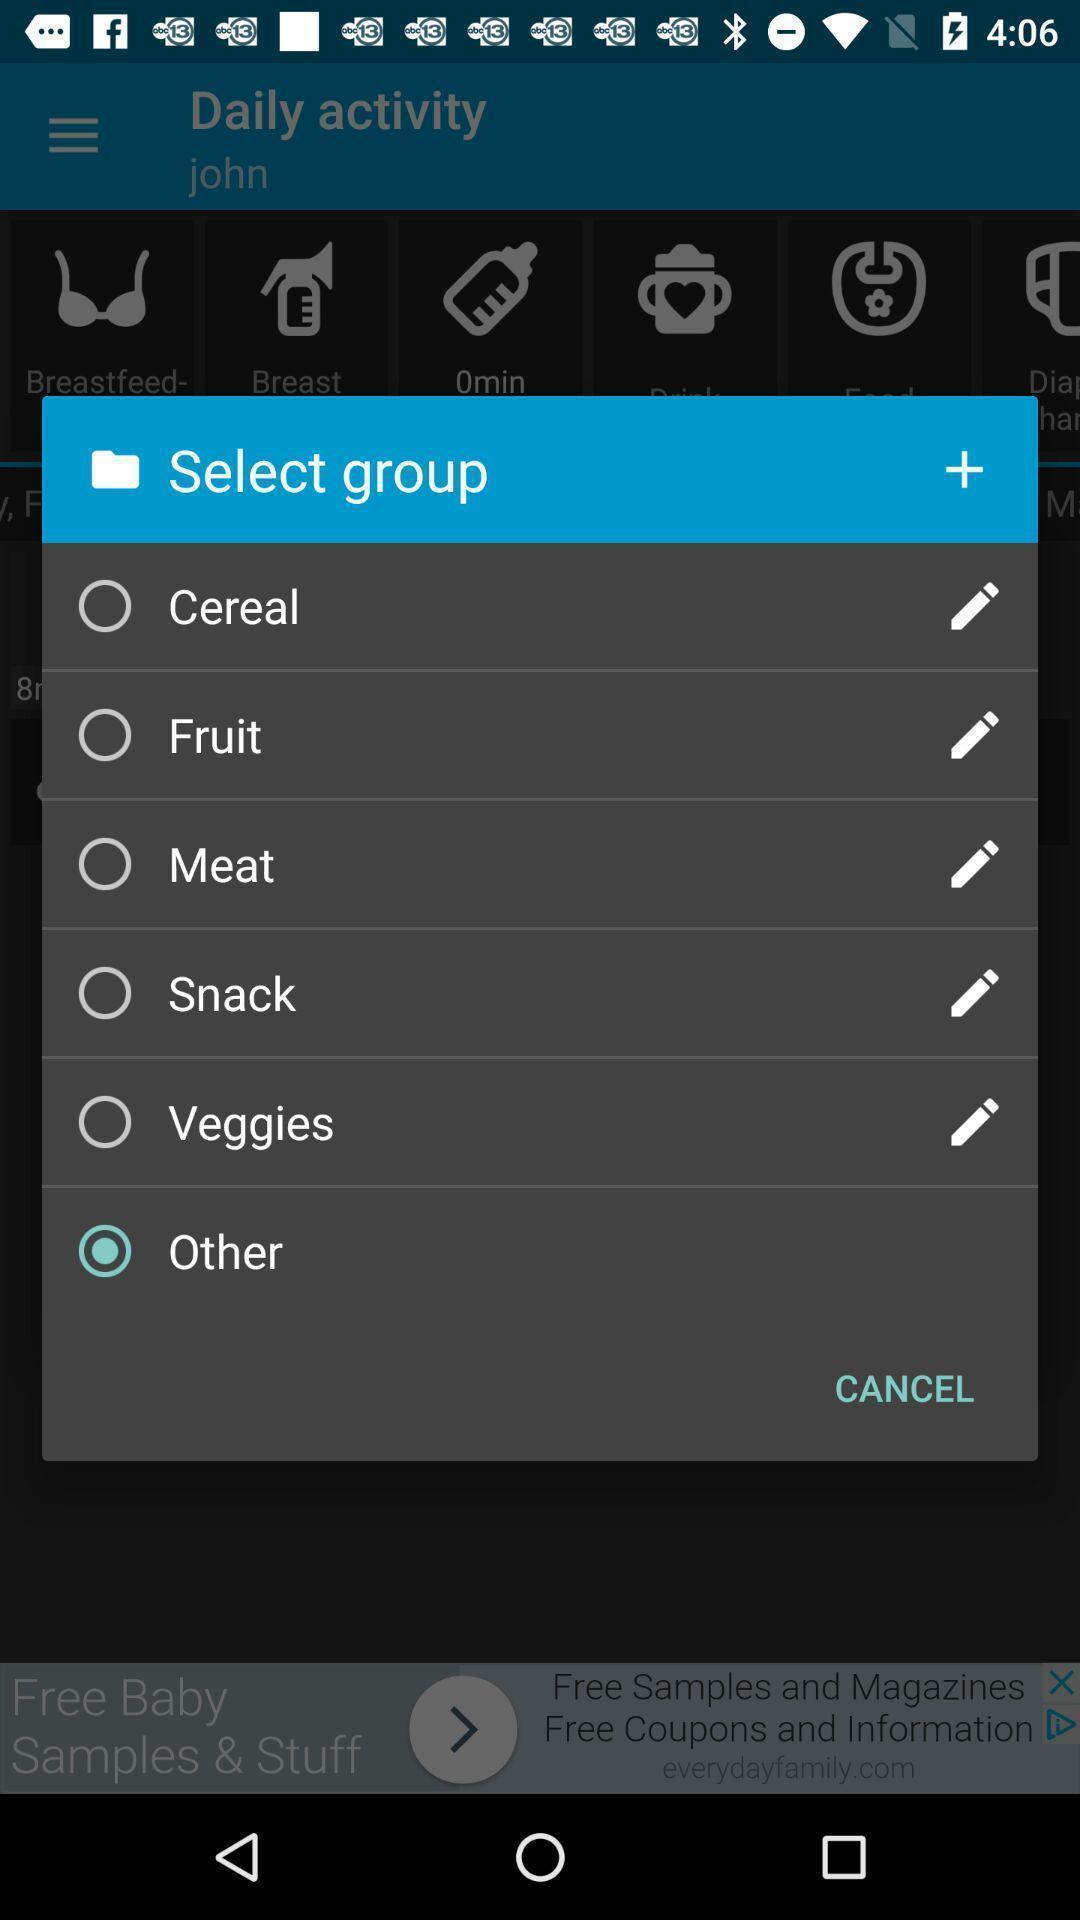Provide a textual representation of this image. Popup showing different option to select. 